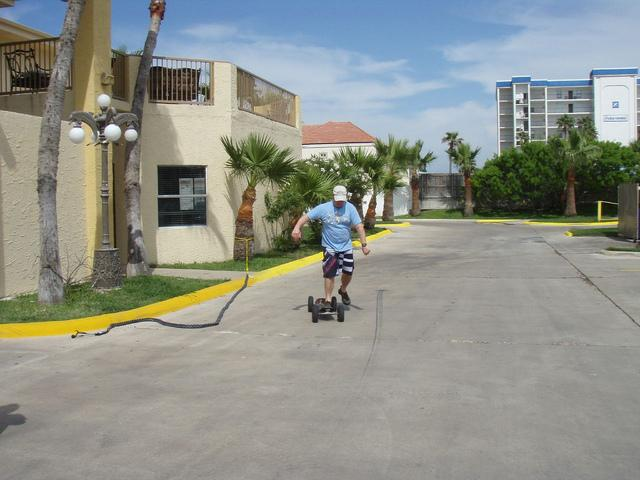What is unusual about the man's skateboard?

Choices:
A) inline
B) primer color
C) miniature
D) big wheels big wheels 